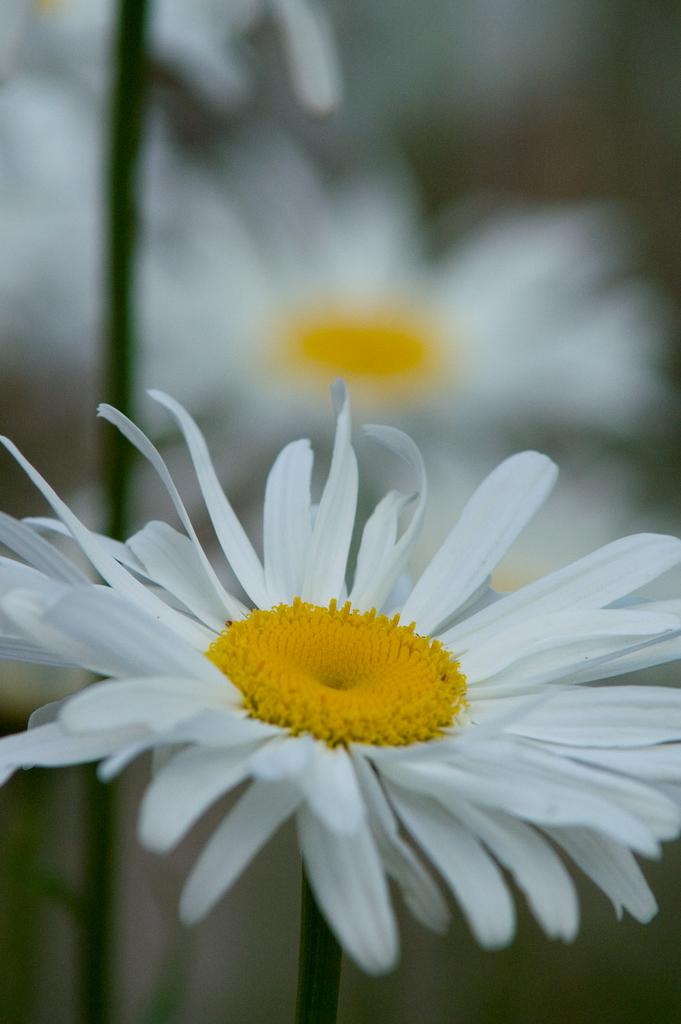What is the main subject in the foreground of the image? There is a white flower in the foreground of the image. What can be seen in the background of the image? There are blurred flowers in the background of the image. What type of toy is the daughter playing with on the sailboat in the image? There is no daughter or sailboat present in the image; it only features a white flower in the foreground and blurred flowers in the background. 